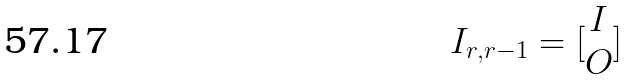<formula> <loc_0><loc_0><loc_500><loc_500>I _ { r , r - 1 } = [ \begin{matrix} I \\ O \end{matrix} ]</formula> 